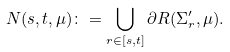Convert formula to latex. <formula><loc_0><loc_0><loc_500><loc_500>N ( s , t , \mu ) \colon = \bigcup _ { r \in [ s , t ] } \partial R ( \Sigma _ { r } ^ { \prime } , \mu ) .</formula> 